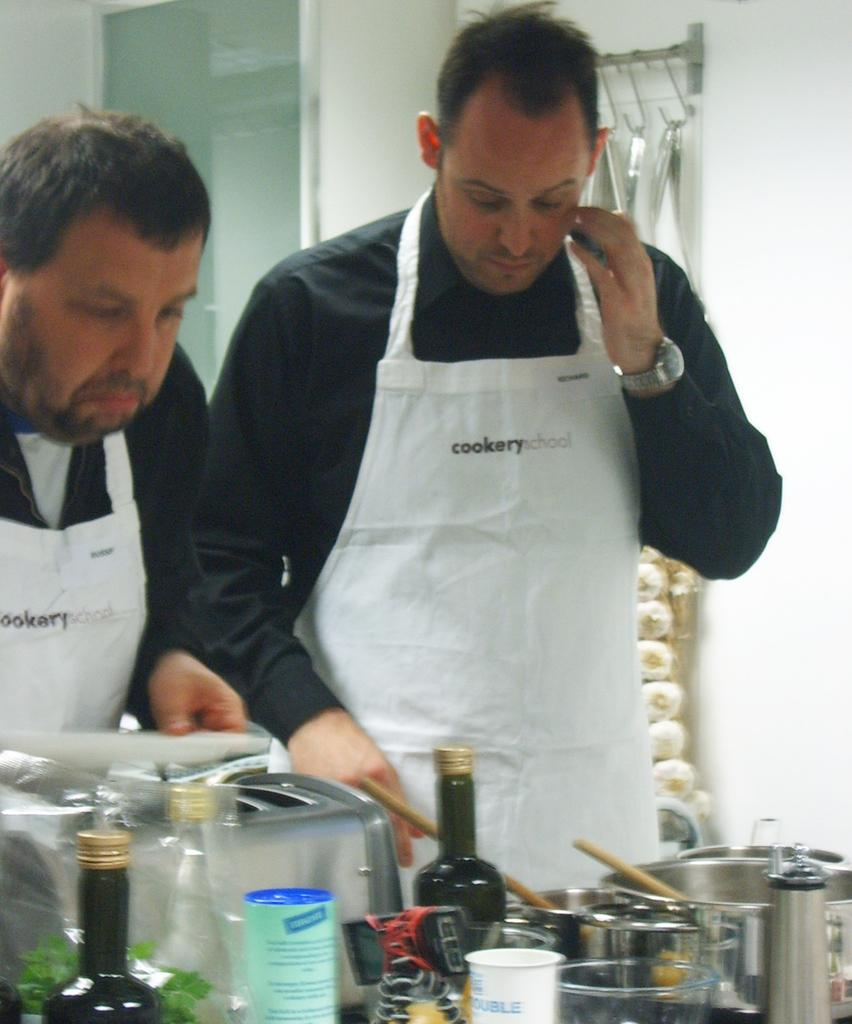How many people are in the image? There are two persons in the image. What are the people wearing? Both persons are wearing black and white aprons. What is in front of one of the persons? There is a table in front of one of the persons. What items can be seen on the table? There are bottles, a bowl, a spatula, a cup, and a machine on the table. What type of calculator is being used by one of the persons in the image? There is no calculator present in the image. Can you describe the coastline visible in the background of the image? There is no coastline visible in the image; it is focused on the two persons and the table in front of one of them. 